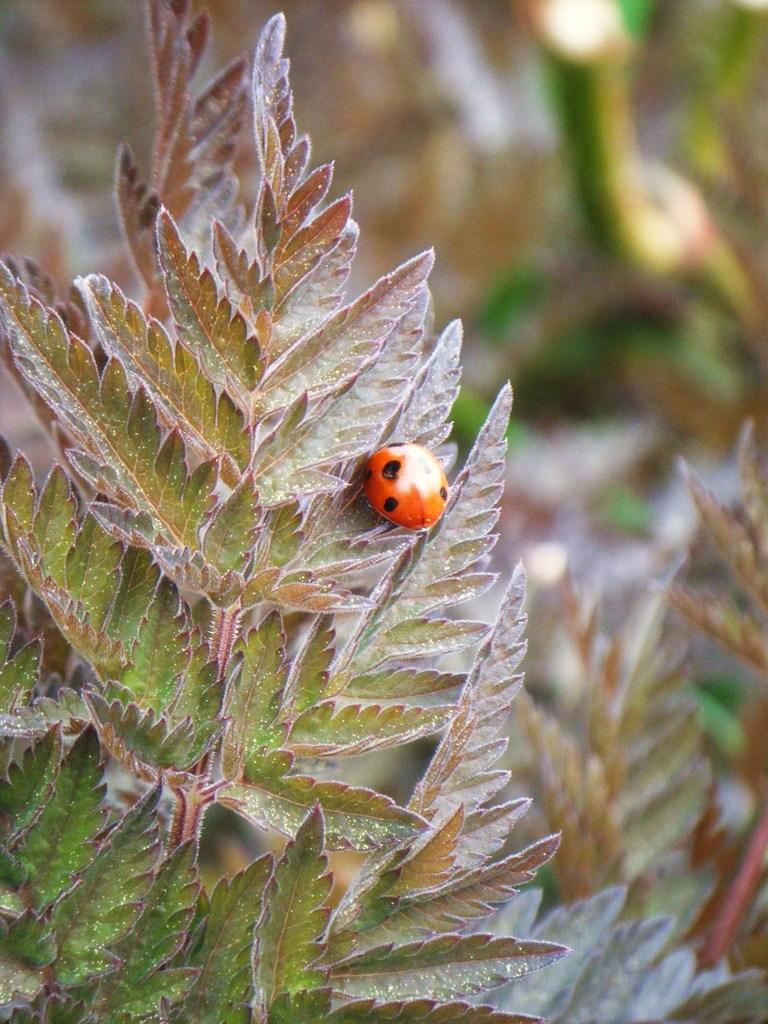What is located in the foreground of the image? There are plants in the foreground of the image. What can be seen on the plants in the image? There is an insect on the plants. What is visible in the background of the image? There are plants visible in the background of the image. What type of soap is being used to clean the bushes in the image? There is no soap or bushes present in the image; it features plants and an insect. 